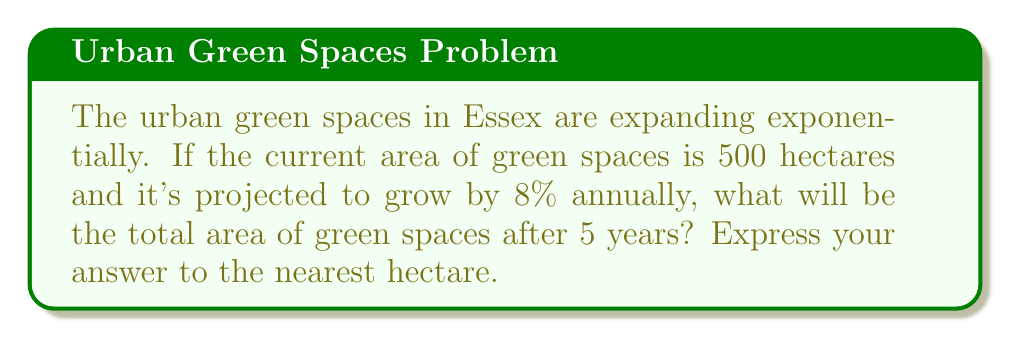Show me your answer to this math problem. Let's approach this step-by-step using an exponential growth function:

1) The exponential growth formula is:
   $A(t) = A_0(1 + r)^t$
   Where:
   $A(t)$ is the final amount
   $A_0$ is the initial amount
   $r$ is the growth rate (as a decimal)
   $t$ is the time in years

2) We know:
   $A_0 = 500$ hectares
   $r = 8\% = 0.08$
   $t = 5$ years

3) Let's substitute these values into our formula:
   $A(5) = 500(1 + 0.08)^5$

4) Now, let's calculate:
   $A(5) = 500(1.08)^5$

5) Using a calculator or computing $(1.08)^5$:
   $A(5) = 500 * 1.4693280768$

6) Multiply:
   $A(5) = 734.6640384$ hectares

7) Rounding to the nearest hectare:
   $A(5) \approx 735$ hectares
Answer: 735 hectares 